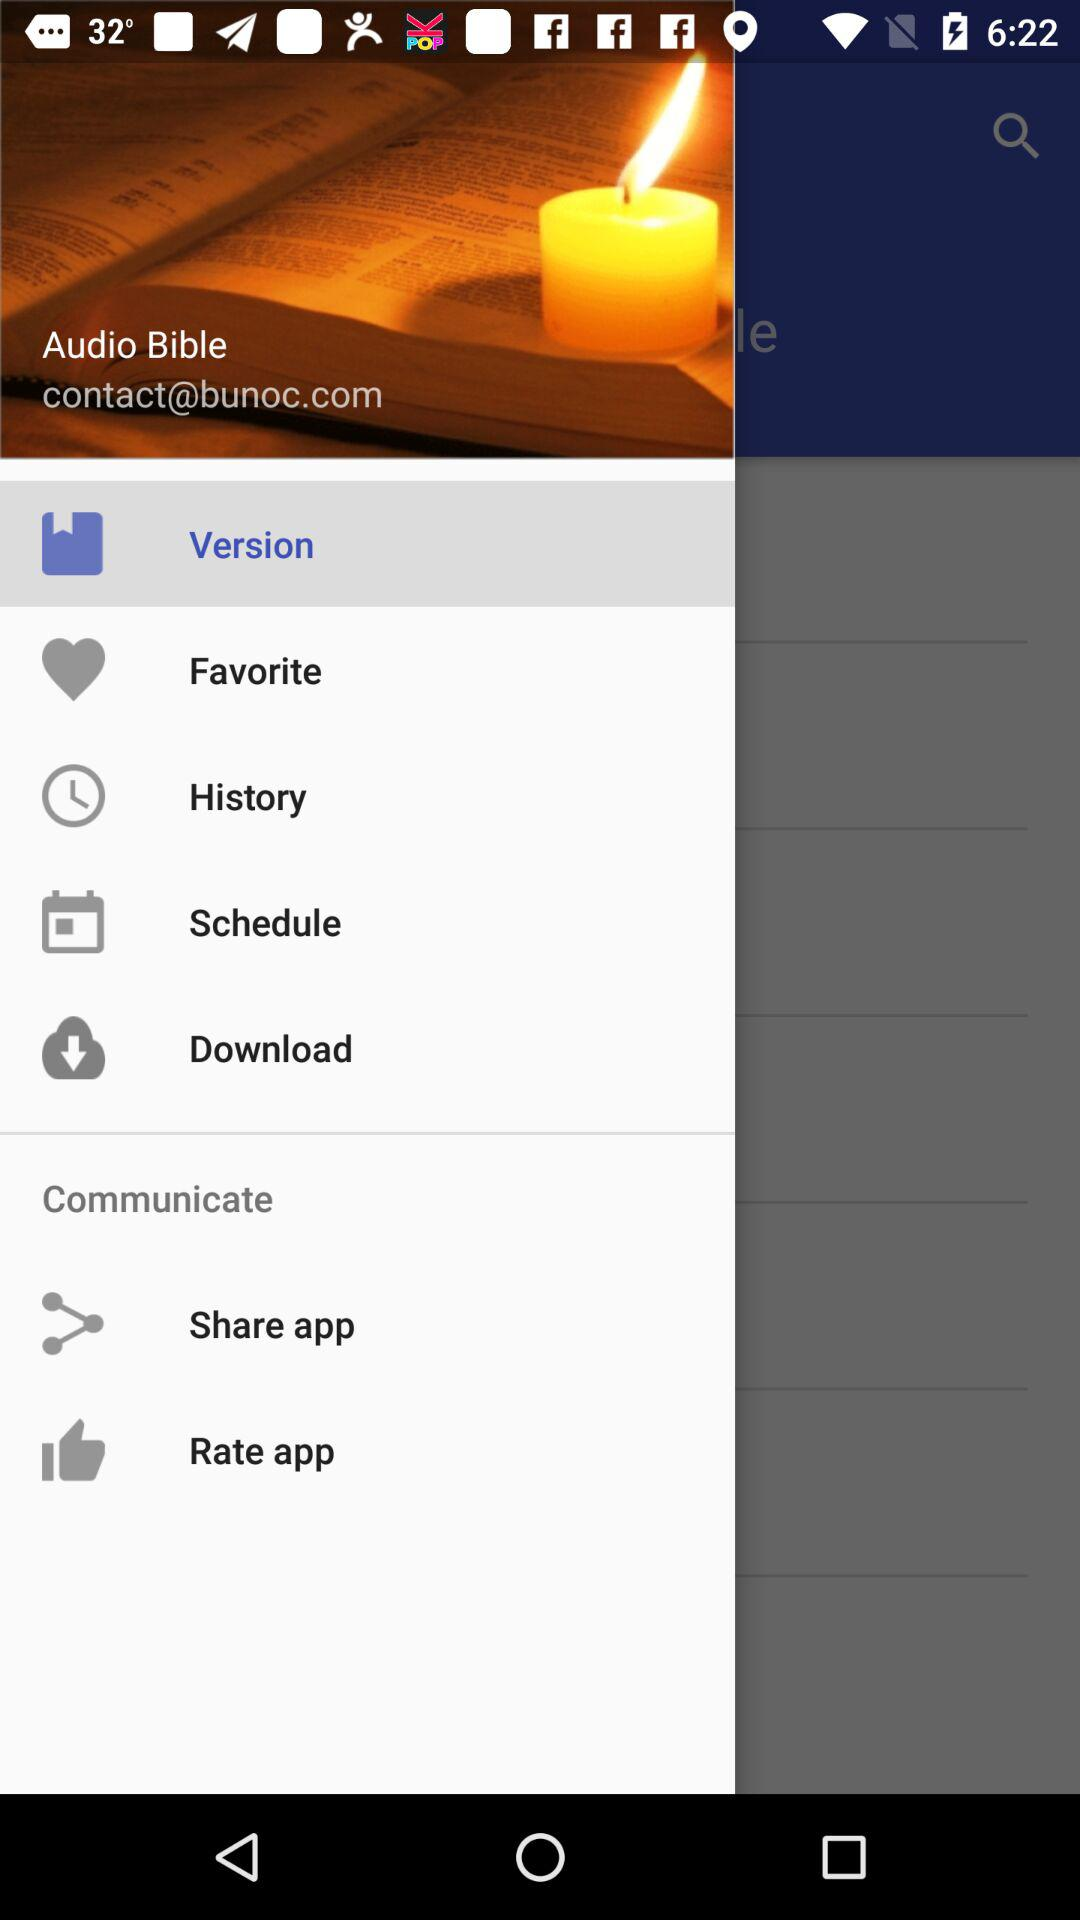What is the name of the application? The name of the application is "Audio Bible". 